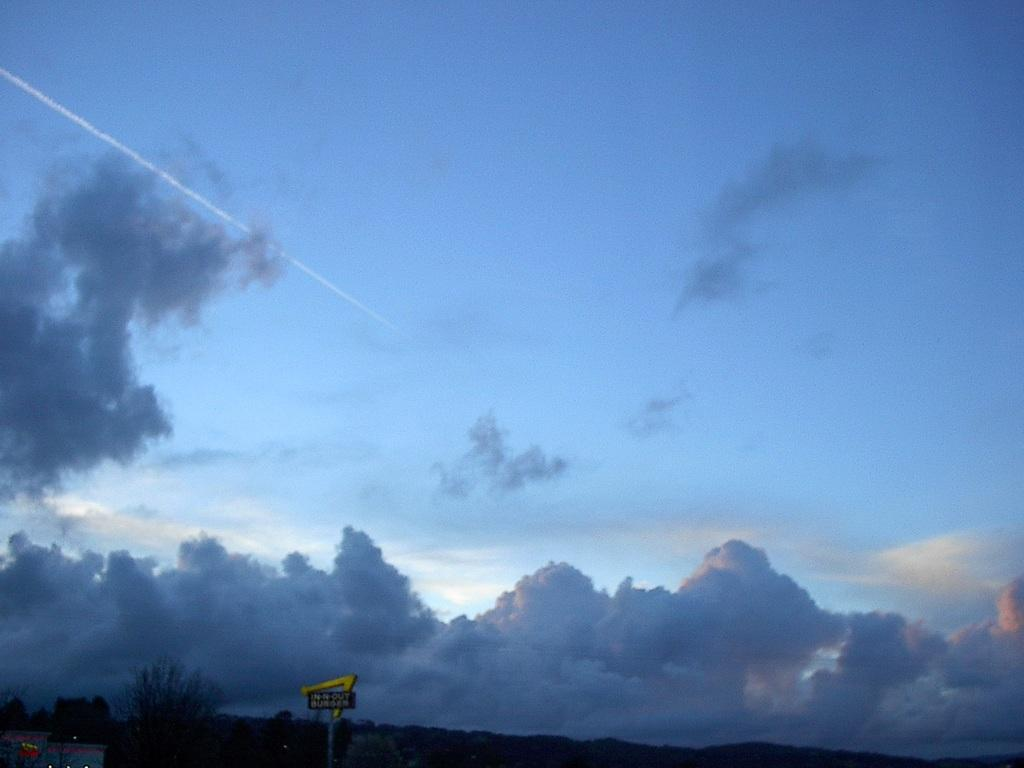What is placed on the road in the image? There is a board on the road. What can be seen around the board? There are trees around the board. What is visible in the background of the image? There is a blue sky in the background. What event might have occurred in the sky? It appears that a meteoroid has passed in the sky. What color is the shirt worn by the meteoroid in the image? There is no meteoroid wearing a shirt in the image, as meteoroids are celestial objects and not human-like beings. 